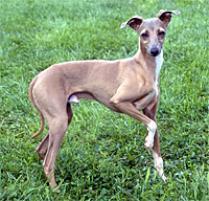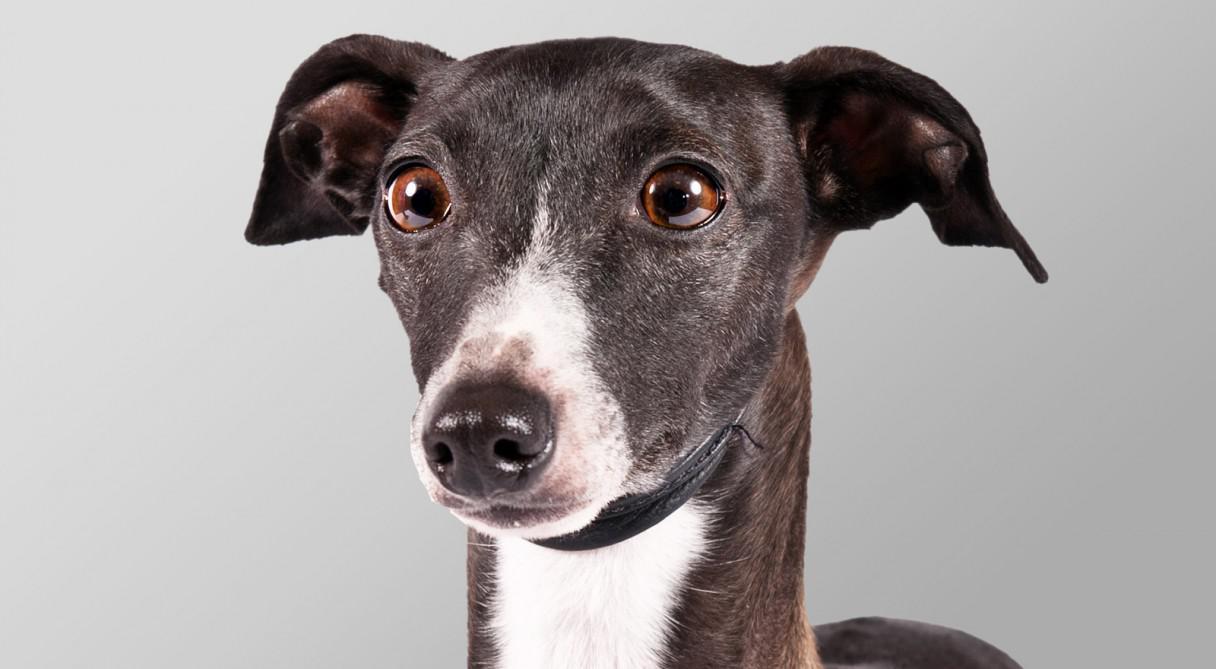The first image is the image on the left, the second image is the image on the right. Examine the images to the left and right. Is the description "There is grass visible in one of the images." accurate? Answer yes or no. Yes. The first image is the image on the left, the second image is the image on the right. For the images shown, is this caption "One dog is in grass." true? Answer yes or no. Yes. 